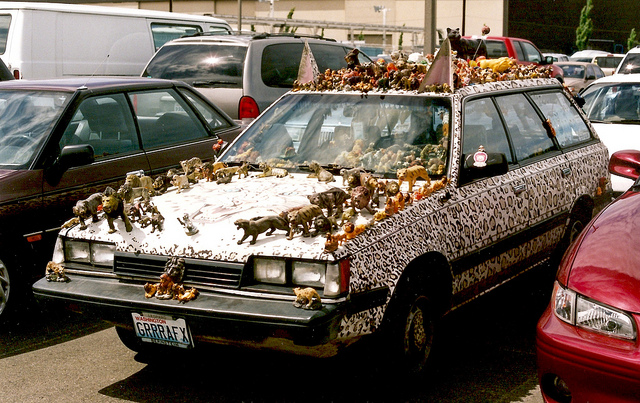Read and extract the text from this image. GRRRAFX 